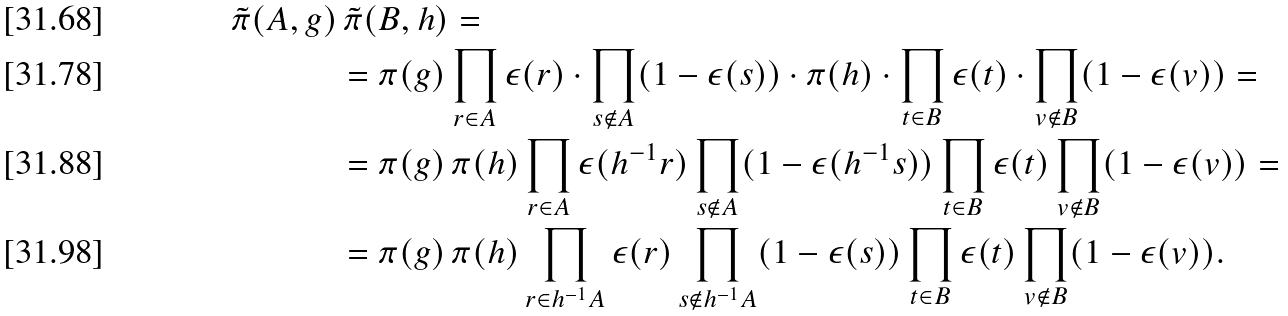<formula> <loc_0><loc_0><loc_500><loc_500>\tilde { \pi } ( A , g ) & \, \tilde { \pi } ( B , h ) = \\ & = \pi ( g ) \prod _ { r \in A } \epsilon ( r ) \cdot \prod _ { s \not \in A } ( 1 - \epsilon ( s ) ) \cdot \pi ( h ) \cdot \prod _ { t \in B } \epsilon ( t ) \cdot \prod _ { v \not \in B } ( 1 - \epsilon ( v ) ) = \\ & = \pi ( g ) \, \pi ( h ) \prod _ { r \in A } \epsilon ( h ^ { - 1 } r ) \prod _ { s \not \in A } ( 1 - \epsilon ( h ^ { - 1 } s ) ) \prod _ { t \in B } \epsilon ( t ) \prod _ { v \not \in B } ( 1 - \epsilon ( v ) ) = \\ & = \pi ( g ) \, \pi ( h ) \prod _ { r \in h ^ { - 1 } A } \epsilon ( r ) \prod _ { s \not \in h ^ { - 1 } A } ( 1 - \epsilon ( s ) ) \prod _ { t \in B } \epsilon ( t ) \prod _ { v \not \in B } ( 1 - \epsilon ( v ) ) .</formula> 